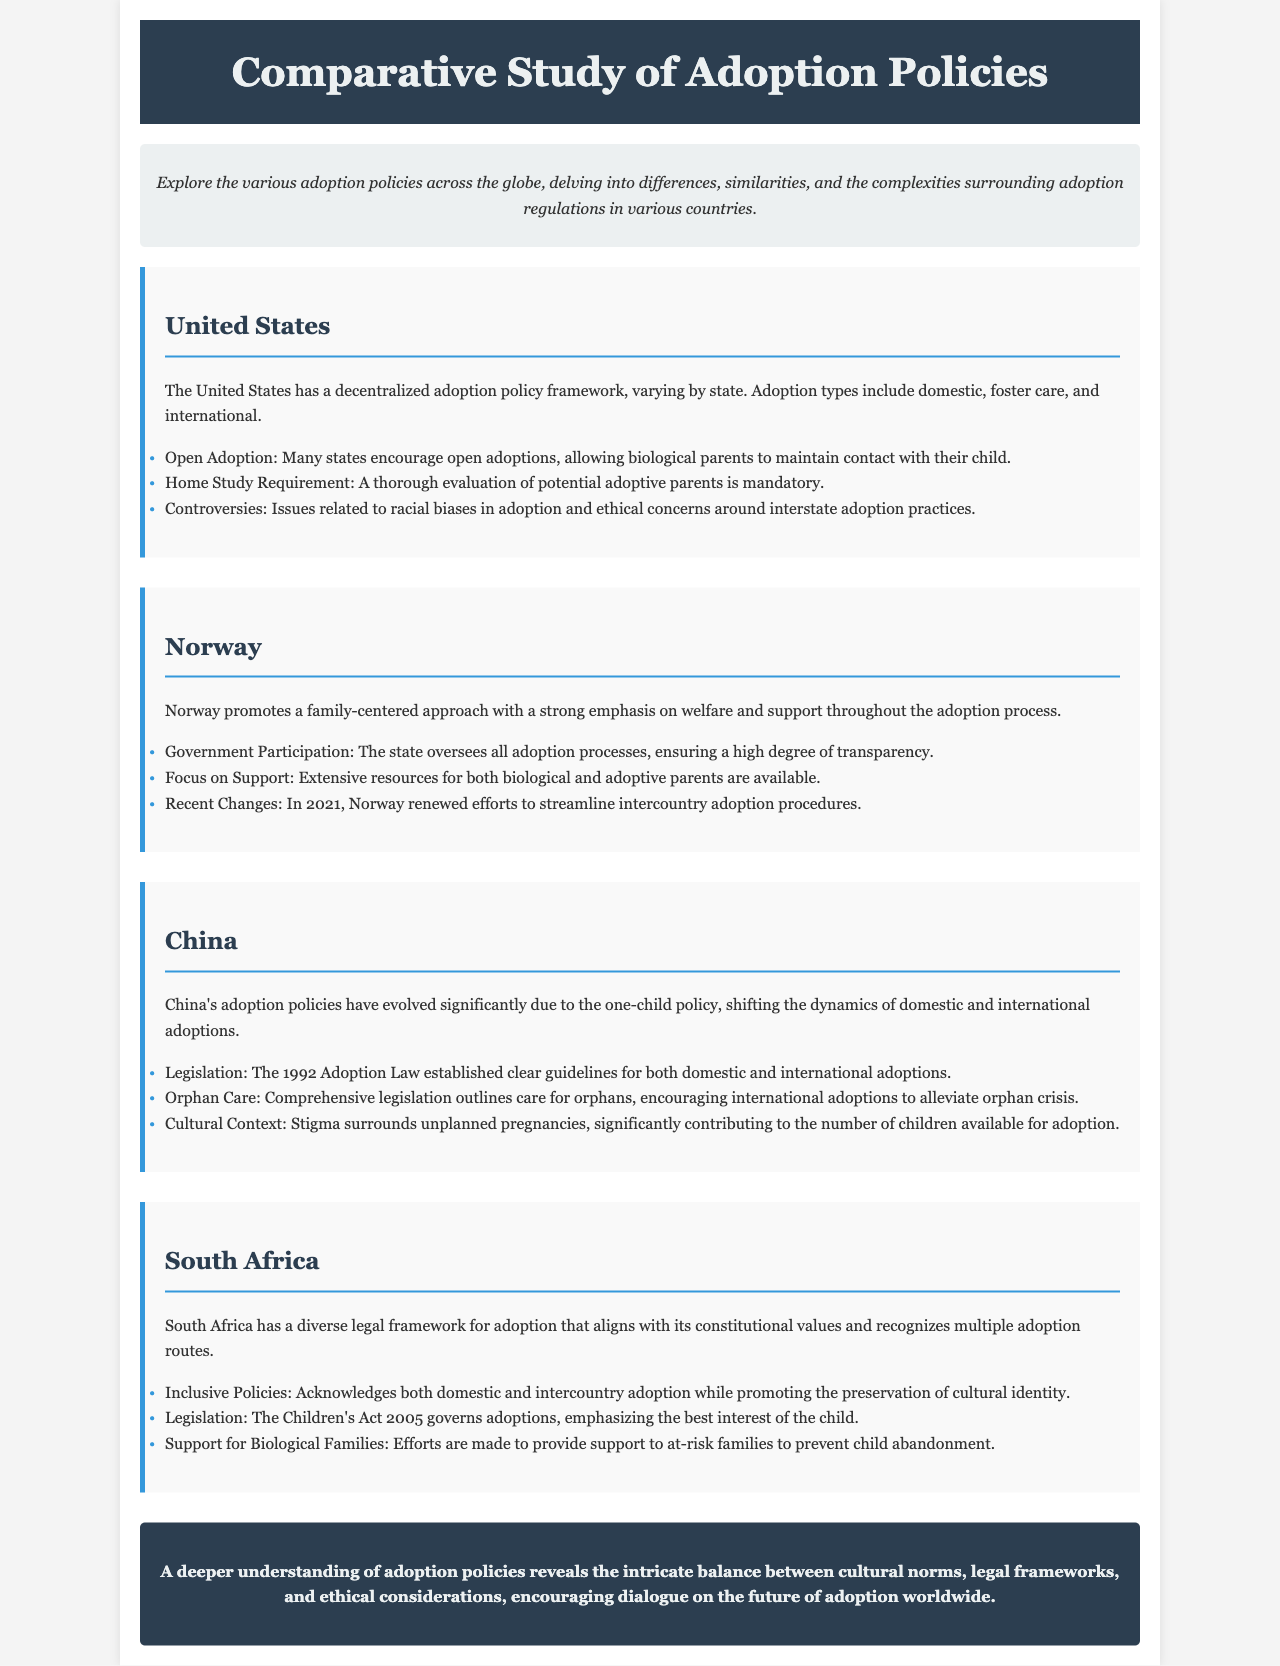What is the title of the brochure? The title is prominently displayed in the header section of the document.
Answer: Comparative Study of Adoption Policies What type of adoption is encouraged in many U.S. states? The document specifies types of adoptions practiced in the U.S.
Answer: Open Adoption What year did Norway renew efforts to streamline intercountry adoption procedures? The specific year is mentioned in the list under Norway's section.
Answer: 2021 What law established guidelines for adoption in China? The document references significant legislation related to adoption in China.
Answer: 1992 Adoption Law Which Act governs adoptions in South Africa? The governing document for adoptions in South Africa is mentioned.
Answer: Children's Act 2005 What approach does Norway promote in its adoption policies? The main focus described in the section on Norway is highlighted.
Answer: Family-centered approach How does South Africa support biological families? The section on South Africa outlines efforts to assist families.
Answer: Provide support to at-risk families What is a significant concern in the United States regarding adoption? The document highlights a controversy related to adoption practices in the U.S.
Answer: Racial biases What does the conclusion emphasize about understanding adoption policies? The conclusion summarizes key themes and insights regarding adoption policies.
Answer: Intricate balance between cultural norms, legal frameworks, and ethical considerations 